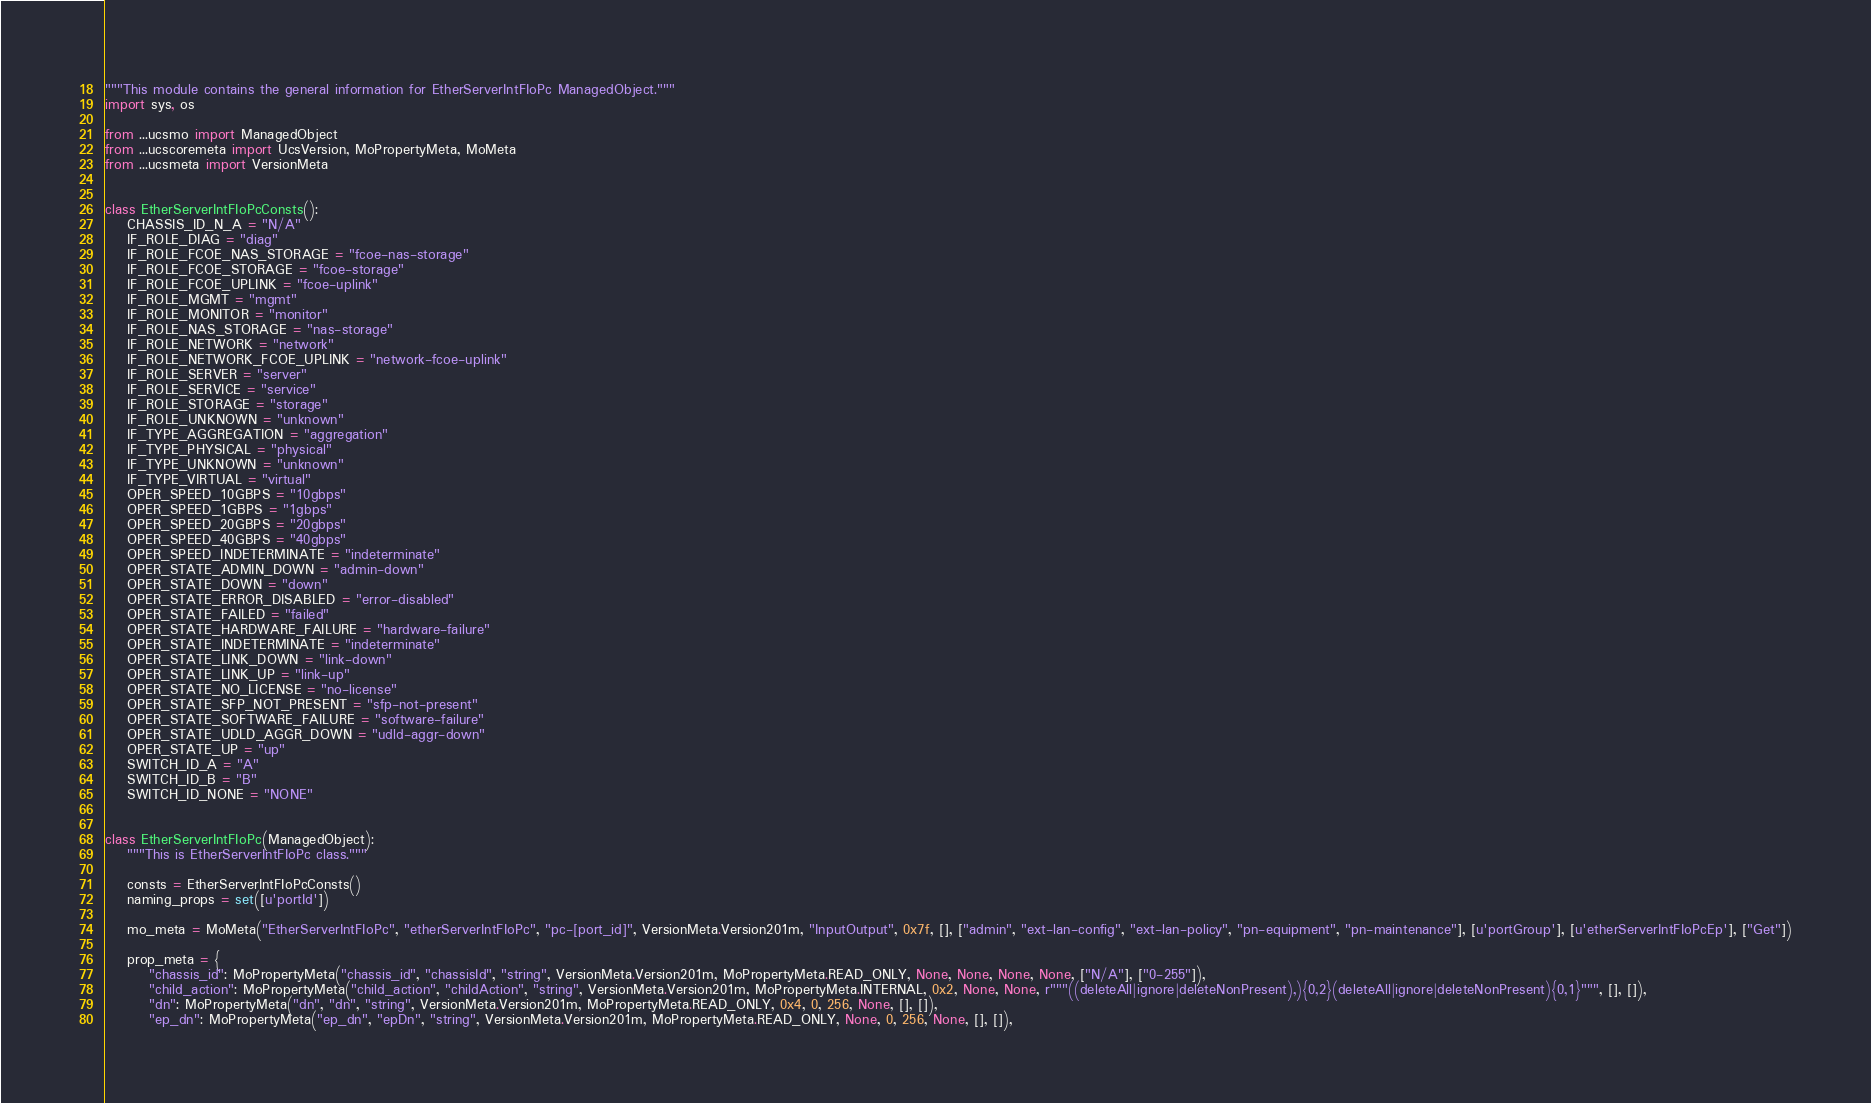Convert code to text. <code><loc_0><loc_0><loc_500><loc_500><_Python_>"""This module contains the general information for EtherServerIntFIoPc ManagedObject."""
import sys, os

from ...ucsmo import ManagedObject
from ...ucscoremeta import UcsVersion, MoPropertyMeta, MoMeta
from ...ucsmeta import VersionMeta


class EtherServerIntFIoPcConsts():
    CHASSIS_ID_N_A = "N/A"
    IF_ROLE_DIAG = "diag"
    IF_ROLE_FCOE_NAS_STORAGE = "fcoe-nas-storage"
    IF_ROLE_FCOE_STORAGE = "fcoe-storage"
    IF_ROLE_FCOE_UPLINK = "fcoe-uplink"
    IF_ROLE_MGMT = "mgmt"
    IF_ROLE_MONITOR = "monitor"
    IF_ROLE_NAS_STORAGE = "nas-storage"
    IF_ROLE_NETWORK = "network"
    IF_ROLE_NETWORK_FCOE_UPLINK = "network-fcoe-uplink"
    IF_ROLE_SERVER = "server"
    IF_ROLE_SERVICE = "service"
    IF_ROLE_STORAGE = "storage"
    IF_ROLE_UNKNOWN = "unknown"
    IF_TYPE_AGGREGATION = "aggregation"
    IF_TYPE_PHYSICAL = "physical"
    IF_TYPE_UNKNOWN = "unknown"
    IF_TYPE_VIRTUAL = "virtual"
    OPER_SPEED_10GBPS = "10gbps"
    OPER_SPEED_1GBPS = "1gbps"
    OPER_SPEED_20GBPS = "20gbps"
    OPER_SPEED_40GBPS = "40gbps"
    OPER_SPEED_INDETERMINATE = "indeterminate"
    OPER_STATE_ADMIN_DOWN = "admin-down"
    OPER_STATE_DOWN = "down"
    OPER_STATE_ERROR_DISABLED = "error-disabled"
    OPER_STATE_FAILED = "failed"
    OPER_STATE_HARDWARE_FAILURE = "hardware-failure"
    OPER_STATE_INDETERMINATE = "indeterminate"
    OPER_STATE_LINK_DOWN = "link-down"
    OPER_STATE_LINK_UP = "link-up"
    OPER_STATE_NO_LICENSE = "no-license"
    OPER_STATE_SFP_NOT_PRESENT = "sfp-not-present"
    OPER_STATE_SOFTWARE_FAILURE = "software-failure"
    OPER_STATE_UDLD_AGGR_DOWN = "udld-aggr-down"
    OPER_STATE_UP = "up"
    SWITCH_ID_A = "A"
    SWITCH_ID_B = "B"
    SWITCH_ID_NONE = "NONE"


class EtherServerIntFIoPc(ManagedObject):
    """This is EtherServerIntFIoPc class."""

    consts = EtherServerIntFIoPcConsts()
    naming_props = set([u'portId'])

    mo_meta = MoMeta("EtherServerIntFIoPc", "etherServerIntFIoPc", "pc-[port_id]", VersionMeta.Version201m, "InputOutput", 0x7f, [], ["admin", "ext-lan-config", "ext-lan-policy", "pn-equipment", "pn-maintenance"], [u'portGroup'], [u'etherServerIntFIoPcEp'], ["Get"])

    prop_meta = {
        "chassis_id": MoPropertyMeta("chassis_id", "chassisId", "string", VersionMeta.Version201m, MoPropertyMeta.READ_ONLY, None, None, None, None, ["N/A"], ["0-255"]), 
        "child_action": MoPropertyMeta("child_action", "childAction", "string", VersionMeta.Version201m, MoPropertyMeta.INTERNAL, 0x2, None, None, r"""((deleteAll|ignore|deleteNonPresent),){0,2}(deleteAll|ignore|deleteNonPresent){0,1}""", [], []), 
        "dn": MoPropertyMeta("dn", "dn", "string", VersionMeta.Version201m, MoPropertyMeta.READ_ONLY, 0x4, 0, 256, None, [], []), 
        "ep_dn": MoPropertyMeta("ep_dn", "epDn", "string", VersionMeta.Version201m, MoPropertyMeta.READ_ONLY, None, 0, 256, None, [], []), </code> 